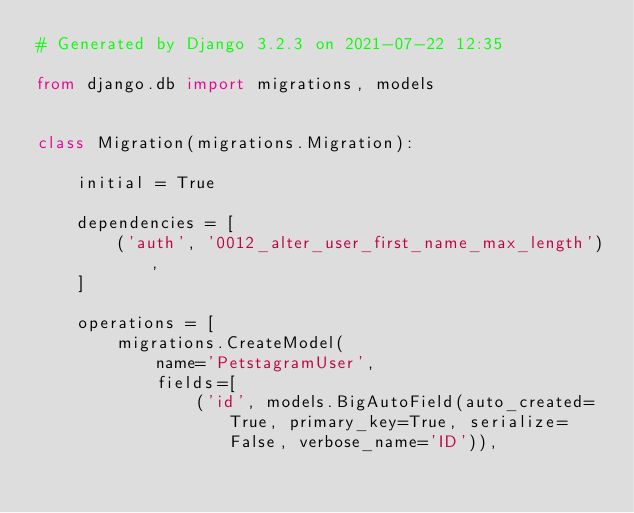<code> <loc_0><loc_0><loc_500><loc_500><_Python_># Generated by Django 3.2.3 on 2021-07-22 12:35

from django.db import migrations, models


class Migration(migrations.Migration):

    initial = True

    dependencies = [
        ('auth', '0012_alter_user_first_name_max_length'),
    ]

    operations = [
        migrations.CreateModel(
            name='PetstagramUser',
            fields=[
                ('id', models.BigAutoField(auto_created=True, primary_key=True, serialize=False, verbose_name='ID')),</code> 